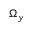<formula> <loc_0><loc_0><loc_500><loc_500>\Omega _ { y }</formula> 